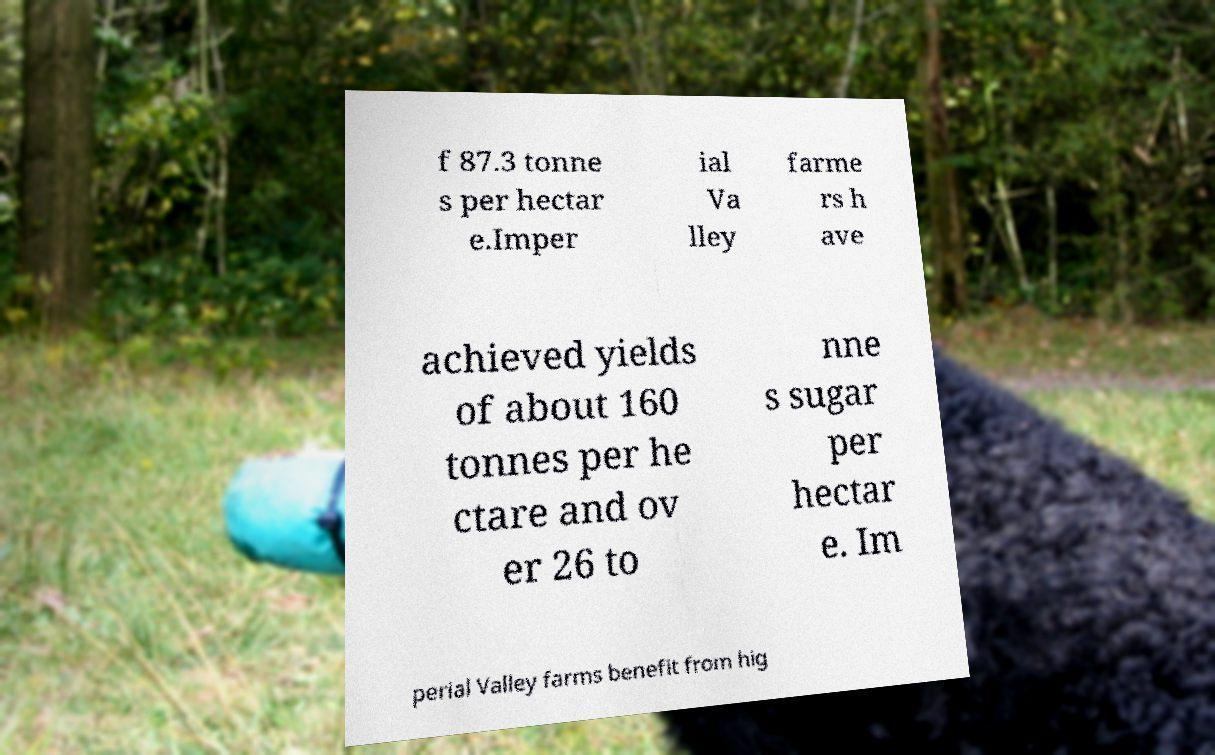Please read and relay the text visible in this image. What does it say? f 87.3 tonne s per hectar e.Imper ial Va lley farme rs h ave achieved yields of about 160 tonnes per he ctare and ov er 26 to nne s sugar per hectar e. Im perial Valley farms benefit from hig 